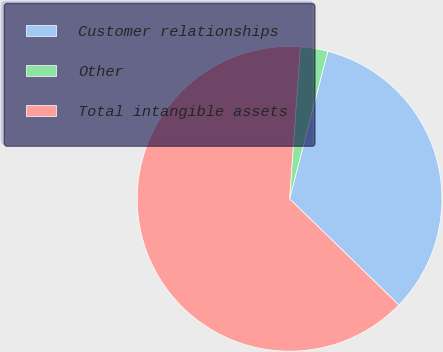Convert chart. <chart><loc_0><loc_0><loc_500><loc_500><pie_chart><fcel>Customer relationships<fcel>Other<fcel>Total intangible assets<nl><fcel>33.23%<fcel>2.91%<fcel>63.86%<nl></chart> 